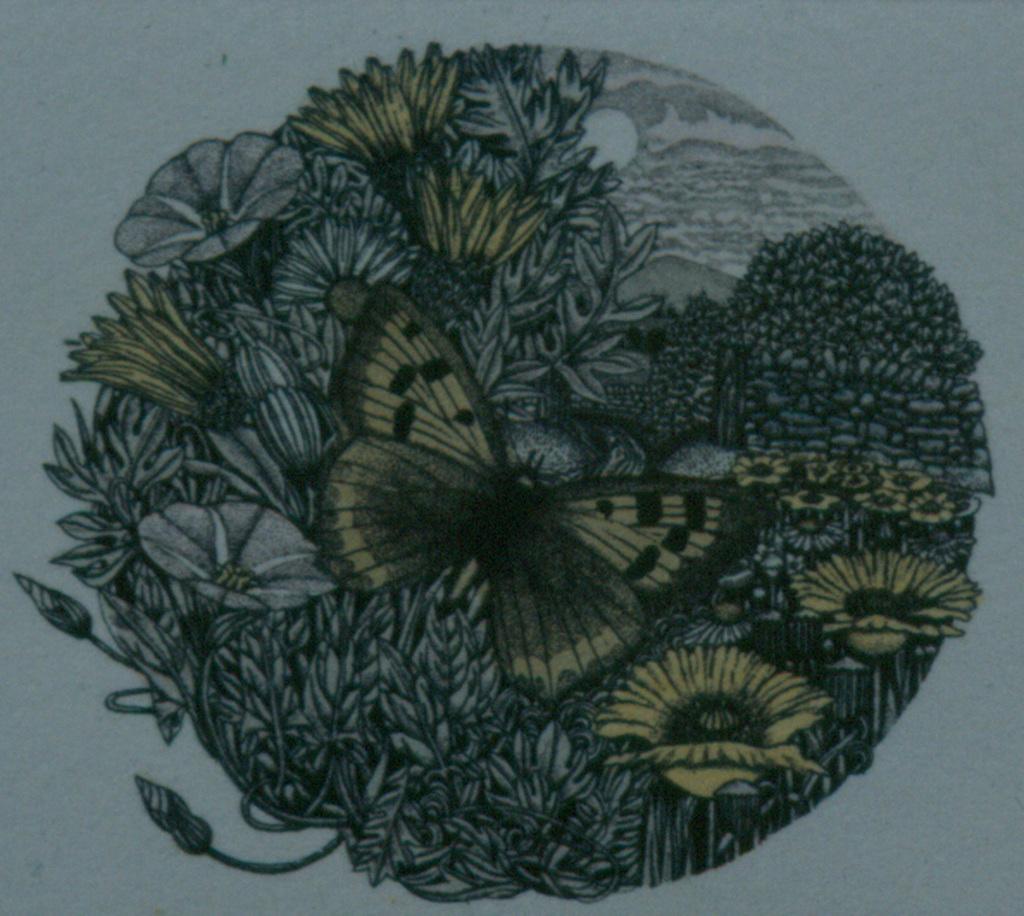In one or two sentences, can you explain what this image depicts? In this picture we can see a painting. Here we can see flowers, butterflies and plants. Here we can see sun and sky. 